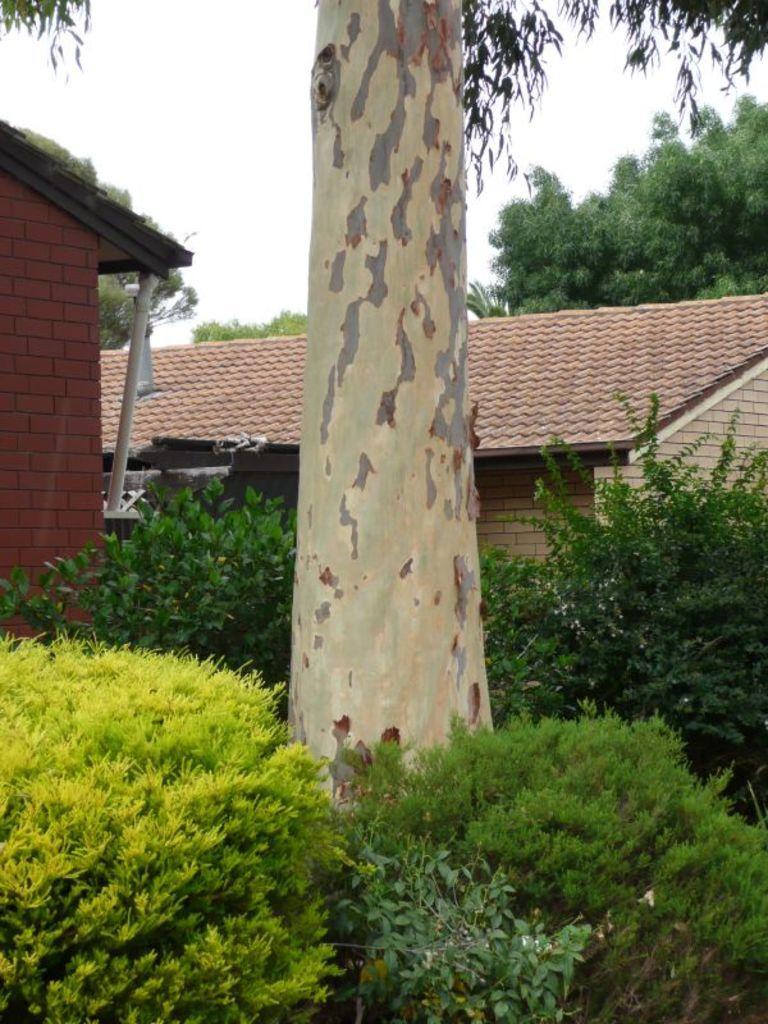Please provide a concise description of this image. In this image there is a tree trunk. Bottom of the image there are plants. Behind there are houses. Background there are trees. Top of the image there are branches having leaves. Behind there is sky. 